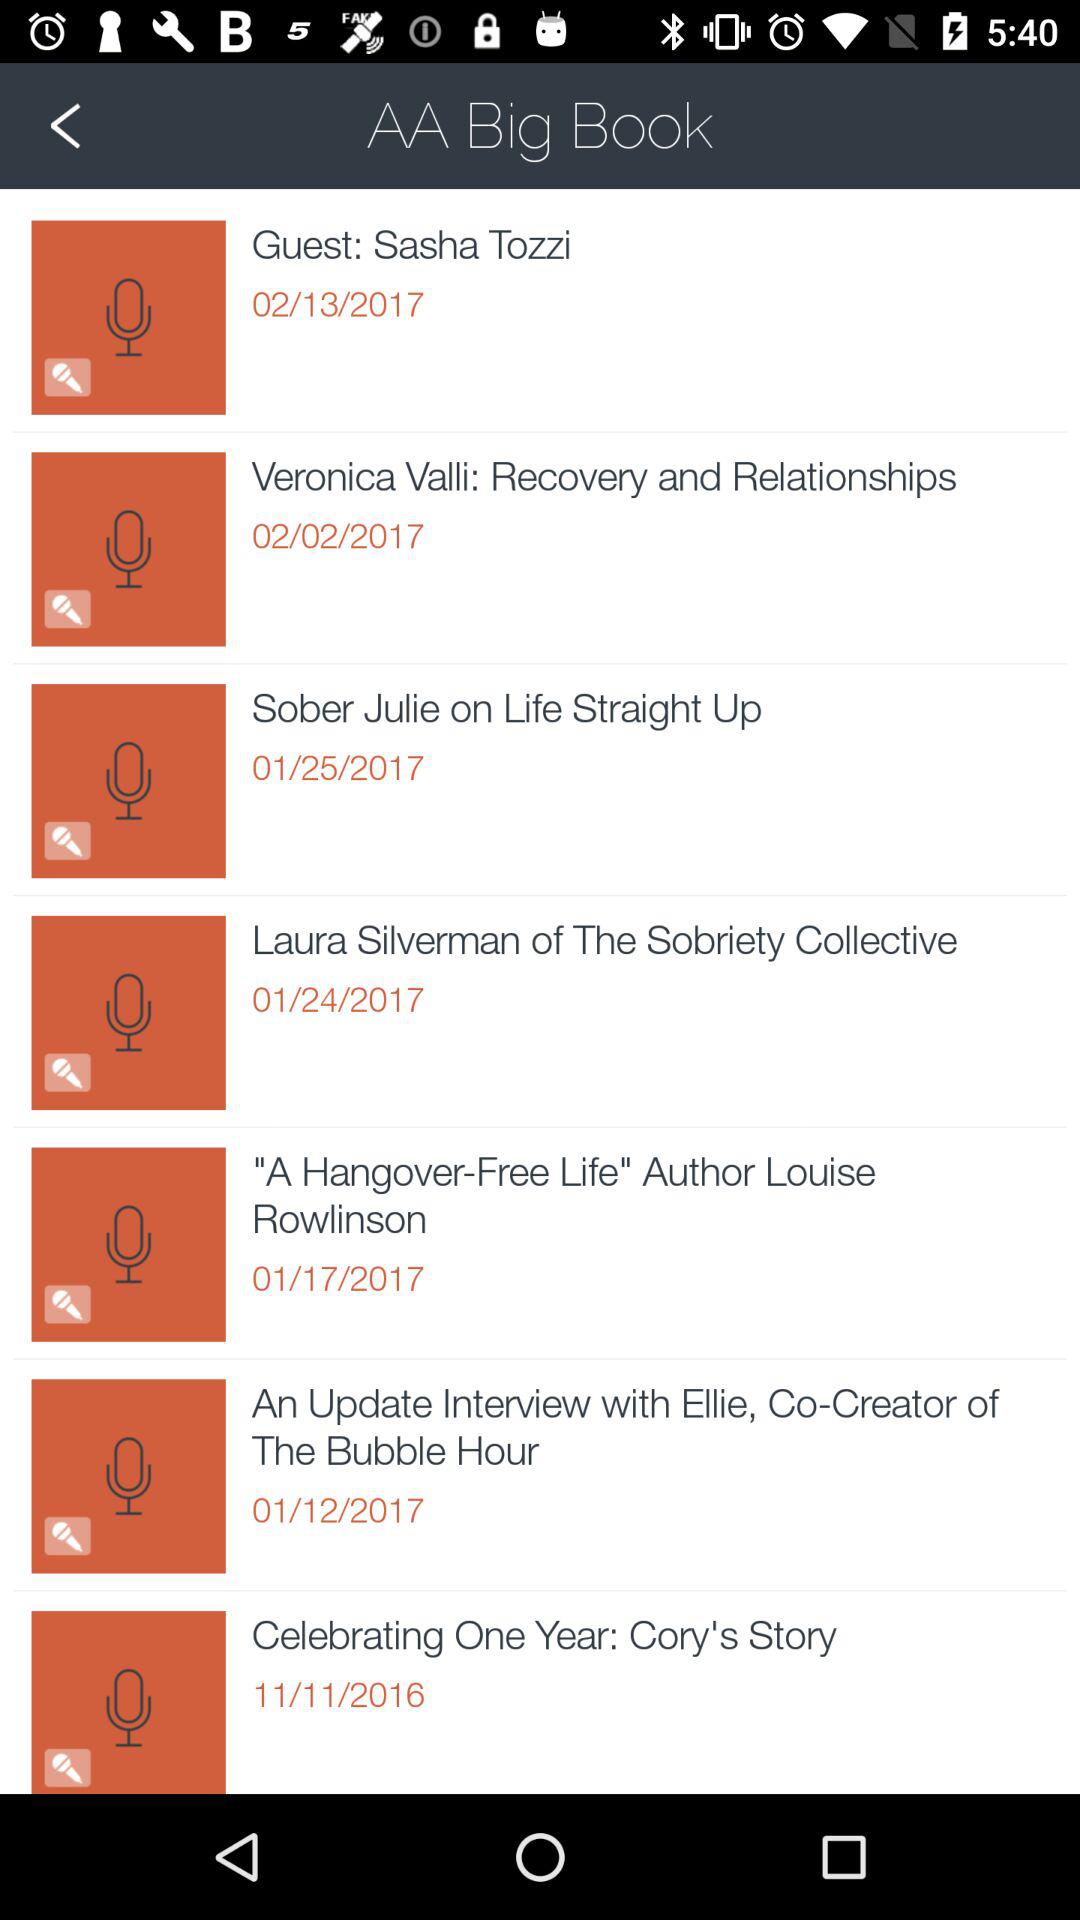What is the date of "Celebrating One Year"? The date of "Celebrating One Year" is November 11, 2016. 